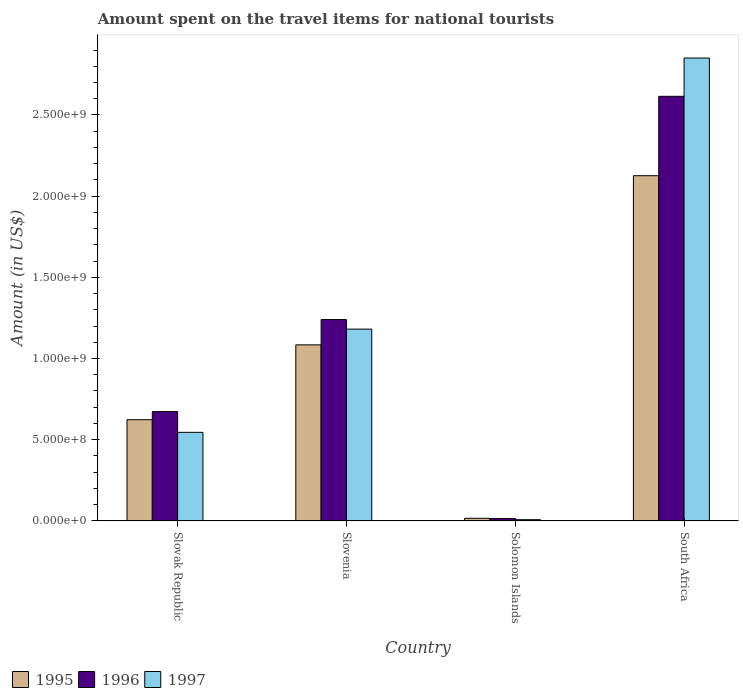Are the number of bars on each tick of the X-axis equal?
Your answer should be compact. Yes. How many bars are there on the 3rd tick from the right?
Provide a succinct answer. 3. What is the label of the 1st group of bars from the left?
Give a very brief answer. Slovak Republic. What is the amount spent on the travel items for national tourists in 1995 in Slovak Republic?
Give a very brief answer. 6.23e+08. Across all countries, what is the maximum amount spent on the travel items for national tourists in 1997?
Your answer should be compact. 2.85e+09. Across all countries, what is the minimum amount spent on the travel items for national tourists in 1996?
Make the answer very short. 1.39e+07. In which country was the amount spent on the travel items for national tourists in 1995 maximum?
Give a very brief answer. South Africa. In which country was the amount spent on the travel items for national tourists in 1995 minimum?
Provide a succinct answer. Solomon Islands. What is the total amount spent on the travel items for national tourists in 1995 in the graph?
Give a very brief answer. 3.85e+09. What is the difference between the amount spent on the travel items for national tourists in 1996 in Slovenia and that in Solomon Islands?
Your response must be concise. 1.23e+09. What is the difference between the amount spent on the travel items for national tourists in 1995 in Slovak Republic and the amount spent on the travel items for national tourists in 1996 in Slovenia?
Provide a succinct answer. -6.17e+08. What is the average amount spent on the travel items for national tourists in 1996 per country?
Give a very brief answer. 1.14e+09. What is the difference between the amount spent on the travel items for national tourists of/in 1997 and amount spent on the travel items for national tourists of/in 1996 in South Africa?
Provide a succinct answer. 2.36e+08. In how many countries, is the amount spent on the travel items for national tourists in 1997 greater than 2300000000 US$?
Provide a succinct answer. 1. What is the ratio of the amount spent on the travel items for national tourists in 1997 in Slovak Republic to that in Slovenia?
Your answer should be very brief. 0.46. Is the amount spent on the travel items for national tourists in 1996 in Slovenia less than that in Solomon Islands?
Your answer should be compact. No. What is the difference between the highest and the second highest amount spent on the travel items for national tourists in 1997?
Provide a succinct answer. 2.31e+09. What is the difference between the highest and the lowest amount spent on the travel items for national tourists in 1997?
Give a very brief answer. 2.84e+09. Is the sum of the amount spent on the travel items for national tourists in 1997 in Solomon Islands and South Africa greater than the maximum amount spent on the travel items for national tourists in 1996 across all countries?
Keep it short and to the point. Yes. What does the 2nd bar from the left in Slovenia represents?
Keep it short and to the point. 1996. Does the graph contain grids?
Keep it short and to the point. No. How many legend labels are there?
Give a very brief answer. 3. How are the legend labels stacked?
Your answer should be compact. Horizontal. What is the title of the graph?
Provide a succinct answer. Amount spent on the travel items for national tourists. Does "1985" appear as one of the legend labels in the graph?
Provide a succinct answer. No. What is the label or title of the X-axis?
Make the answer very short. Country. What is the label or title of the Y-axis?
Your answer should be very brief. Amount (in US$). What is the Amount (in US$) of 1995 in Slovak Republic?
Ensure brevity in your answer.  6.23e+08. What is the Amount (in US$) of 1996 in Slovak Republic?
Offer a terse response. 6.73e+08. What is the Amount (in US$) in 1997 in Slovak Republic?
Keep it short and to the point. 5.45e+08. What is the Amount (in US$) of 1995 in Slovenia?
Give a very brief answer. 1.08e+09. What is the Amount (in US$) of 1996 in Slovenia?
Make the answer very short. 1.24e+09. What is the Amount (in US$) in 1997 in Slovenia?
Ensure brevity in your answer.  1.18e+09. What is the Amount (in US$) of 1995 in Solomon Islands?
Your answer should be compact. 1.57e+07. What is the Amount (in US$) of 1996 in Solomon Islands?
Provide a succinct answer. 1.39e+07. What is the Amount (in US$) of 1997 in Solomon Islands?
Provide a short and direct response. 7.10e+06. What is the Amount (in US$) in 1995 in South Africa?
Your answer should be compact. 2.13e+09. What is the Amount (in US$) in 1996 in South Africa?
Offer a very short reply. 2.62e+09. What is the Amount (in US$) in 1997 in South Africa?
Your response must be concise. 2.85e+09. Across all countries, what is the maximum Amount (in US$) of 1995?
Provide a succinct answer. 2.13e+09. Across all countries, what is the maximum Amount (in US$) in 1996?
Ensure brevity in your answer.  2.62e+09. Across all countries, what is the maximum Amount (in US$) of 1997?
Your response must be concise. 2.85e+09. Across all countries, what is the minimum Amount (in US$) in 1995?
Provide a succinct answer. 1.57e+07. Across all countries, what is the minimum Amount (in US$) in 1996?
Your response must be concise. 1.39e+07. Across all countries, what is the minimum Amount (in US$) in 1997?
Provide a short and direct response. 7.10e+06. What is the total Amount (in US$) of 1995 in the graph?
Your response must be concise. 3.85e+09. What is the total Amount (in US$) of 1996 in the graph?
Ensure brevity in your answer.  4.54e+09. What is the total Amount (in US$) in 1997 in the graph?
Keep it short and to the point. 4.58e+09. What is the difference between the Amount (in US$) in 1995 in Slovak Republic and that in Slovenia?
Offer a terse response. -4.61e+08. What is the difference between the Amount (in US$) of 1996 in Slovak Republic and that in Slovenia?
Keep it short and to the point. -5.67e+08. What is the difference between the Amount (in US$) in 1997 in Slovak Republic and that in Slovenia?
Your answer should be very brief. -6.36e+08. What is the difference between the Amount (in US$) in 1995 in Slovak Republic and that in Solomon Islands?
Give a very brief answer. 6.07e+08. What is the difference between the Amount (in US$) in 1996 in Slovak Republic and that in Solomon Islands?
Your response must be concise. 6.59e+08. What is the difference between the Amount (in US$) in 1997 in Slovak Republic and that in Solomon Islands?
Your response must be concise. 5.38e+08. What is the difference between the Amount (in US$) in 1995 in Slovak Republic and that in South Africa?
Keep it short and to the point. -1.50e+09. What is the difference between the Amount (in US$) of 1996 in Slovak Republic and that in South Africa?
Your answer should be very brief. -1.94e+09. What is the difference between the Amount (in US$) in 1997 in Slovak Republic and that in South Africa?
Make the answer very short. -2.31e+09. What is the difference between the Amount (in US$) in 1995 in Slovenia and that in Solomon Islands?
Offer a very short reply. 1.07e+09. What is the difference between the Amount (in US$) in 1996 in Slovenia and that in Solomon Islands?
Give a very brief answer. 1.23e+09. What is the difference between the Amount (in US$) in 1997 in Slovenia and that in Solomon Islands?
Offer a very short reply. 1.17e+09. What is the difference between the Amount (in US$) in 1995 in Slovenia and that in South Africa?
Give a very brief answer. -1.04e+09. What is the difference between the Amount (in US$) in 1996 in Slovenia and that in South Africa?
Make the answer very short. -1.38e+09. What is the difference between the Amount (in US$) of 1997 in Slovenia and that in South Africa?
Make the answer very short. -1.67e+09. What is the difference between the Amount (in US$) in 1995 in Solomon Islands and that in South Africa?
Your answer should be compact. -2.11e+09. What is the difference between the Amount (in US$) of 1996 in Solomon Islands and that in South Africa?
Keep it short and to the point. -2.60e+09. What is the difference between the Amount (in US$) in 1997 in Solomon Islands and that in South Africa?
Your response must be concise. -2.84e+09. What is the difference between the Amount (in US$) in 1995 in Slovak Republic and the Amount (in US$) in 1996 in Slovenia?
Your answer should be very brief. -6.17e+08. What is the difference between the Amount (in US$) of 1995 in Slovak Republic and the Amount (in US$) of 1997 in Slovenia?
Ensure brevity in your answer.  -5.58e+08. What is the difference between the Amount (in US$) of 1996 in Slovak Republic and the Amount (in US$) of 1997 in Slovenia?
Your answer should be very brief. -5.08e+08. What is the difference between the Amount (in US$) in 1995 in Slovak Republic and the Amount (in US$) in 1996 in Solomon Islands?
Your answer should be very brief. 6.09e+08. What is the difference between the Amount (in US$) in 1995 in Slovak Republic and the Amount (in US$) in 1997 in Solomon Islands?
Make the answer very short. 6.16e+08. What is the difference between the Amount (in US$) of 1996 in Slovak Republic and the Amount (in US$) of 1997 in Solomon Islands?
Make the answer very short. 6.66e+08. What is the difference between the Amount (in US$) of 1995 in Slovak Republic and the Amount (in US$) of 1996 in South Africa?
Your answer should be compact. -1.99e+09. What is the difference between the Amount (in US$) in 1995 in Slovak Republic and the Amount (in US$) in 1997 in South Africa?
Offer a terse response. -2.23e+09. What is the difference between the Amount (in US$) of 1996 in Slovak Republic and the Amount (in US$) of 1997 in South Africa?
Your answer should be very brief. -2.18e+09. What is the difference between the Amount (in US$) in 1995 in Slovenia and the Amount (in US$) in 1996 in Solomon Islands?
Your response must be concise. 1.07e+09. What is the difference between the Amount (in US$) in 1995 in Slovenia and the Amount (in US$) in 1997 in Solomon Islands?
Offer a very short reply. 1.08e+09. What is the difference between the Amount (in US$) in 1996 in Slovenia and the Amount (in US$) in 1997 in Solomon Islands?
Give a very brief answer. 1.23e+09. What is the difference between the Amount (in US$) in 1995 in Slovenia and the Amount (in US$) in 1996 in South Africa?
Give a very brief answer. -1.53e+09. What is the difference between the Amount (in US$) of 1995 in Slovenia and the Amount (in US$) of 1997 in South Africa?
Offer a very short reply. -1.77e+09. What is the difference between the Amount (in US$) in 1996 in Slovenia and the Amount (in US$) in 1997 in South Africa?
Your response must be concise. -1.61e+09. What is the difference between the Amount (in US$) of 1995 in Solomon Islands and the Amount (in US$) of 1996 in South Africa?
Your answer should be compact. -2.60e+09. What is the difference between the Amount (in US$) in 1995 in Solomon Islands and the Amount (in US$) in 1997 in South Africa?
Your answer should be very brief. -2.84e+09. What is the difference between the Amount (in US$) in 1996 in Solomon Islands and the Amount (in US$) in 1997 in South Africa?
Make the answer very short. -2.84e+09. What is the average Amount (in US$) of 1995 per country?
Your answer should be very brief. 9.62e+08. What is the average Amount (in US$) of 1996 per country?
Ensure brevity in your answer.  1.14e+09. What is the average Amount (in US$) in 1997 per country?
Your answer should be very brief. 1.15e+09. What is the difference between the Amount (in US$) in 1995 and Amount (in US$) in 1996 in Slovak Republic?
Keep it short and to the point. -5.00e+07. What is the difference between the Amount (in US$) of 1995 and Amount (in US$) of 1997 in Slovak Republic?
Give a very brief answer. 7.80e+07. What is the difference between the Amount (in US$) in 1996 and Amount (in US$) in 1997 in Slovak Republic?
Your answer should be compact. 1.28e+08. What is the difference between the Amount (in US$) in 1995 and Amount (in US$) in 1996 in Slovenia?
Offer a terse response. -1.56e+08. What is the difference between the Amount (in US$) of 1995 and Amount (in US$) of 1997 in Slovenia?
Provide a succinct answer. -9.70e+07. What is the difference between the Amount (in US$) in 1996 and Amount (in US$) in 1997 in Slovenia?
Offer a terse response. 5.90e+07. What is the difference between the Amount (in US$) in 1995 and Amount (in US$) in 1996 in Solomon Islands?
Offer a terse response. 1.80e+06. What is the difference between the Amount (in US$) of 1995 and Amount (in US$) of 1997 in Solomon Islands?
Your answer should be compact. 8.60e+06. What is the difference between the Amount (in US$) of 1996 and Amount (in US$) of 1997 in Solomon Islands?
Make the answer very short. 6.80e+06. What is the difference between the Amount (in US$) of 1995 and Amount (in US$) of 1996 in South Africa?
Your answer should be compact. -4.89e+08. What is the difference between the Amount (in US$) in 1995 and Amount (in US$) in 1997 in South Africa?
Ensure brevity in your answer.  -7.25e+08. What is the difference between the Amount (in US$) in 1996 and Amount (in US$) in 1997 in South Africa?
Provide a succinct answer. -2.36e+08. What is the ratio of the Amount (in US$) of 1995 in Slovak Republic to that in Slovenia?
Offer a very short reply. 0.57. What is the ratio of the Amount (in US$) in 1996 in Slovak Republic to that in Slovenia?
Your answer should be compact. 0.54. What is the ratio of the Amount (in US$) in 1997 in Slovak Republic to that in Slovenia?
Provide a short and direct response. 0.46. What is the ratio of the Amount (in US$) of 1995 in Slovak Republic to that in Solomon Islands?
Your answer should be compact. 39.68. What is the ratio of the Amount (in US$) in 1996 in Slovak Republic to that in Solomon Islands?
Your answer should be very brief. 48.42. What is the ratio of the Amount (in US$) of 1997 in Slovak Republic to that in Solomon Islands?
Provide a short and direct response. 76.76. What is the ratio of the Amount (in US$) of 1995 in Slovak Republic to that in South Africa?
Give a very brief answer. 0.29. What is the ratio of the Amount (in US$) of 1996 in Slovak Republic to that in South Africa?
Your answer should be very brief. 0.26. What is the ratio of the Amount (in US$) of 1997 in Slovak Republic to that in South Africa?
Provide a succinct answer. 0.19. What is the ratio of the Amount (in US$) in 1995 in Slovenia to that in Solomon Islands?
Offer a very short reply. 69.04. What is the ratio of the Amount (in US$) in 1996 in Slovenia to that in Solomon Islands?
Keep it short and to the point. 89.21. What is the ratio of the Amount (in US$) of 1997 in Slovenia to that in Solomon Islands?
Provide a short and direct response. 166.34. What is the ratio of the Amount (in US$) in 1995 in Slovenia to that in South Africa?
Offer a very short reply. 0.51. What is the ratio of the Amount (in US$) in 1996 in Slovenia to that in South Africa?
Your answer should be compact. 0.47. What is the ratio of the Amount (in US$) of 1997 in Slovenia to that in South Africa?
Provide a short and direct response. 0.41. What is the ratio of the Amount (in US$) in 1995 in Solomon Islands to that in South Africa?
Provide a succinct answer. 0.01. What is the ratio of the Amount (in US$) in 1996 in Solomon Islands to that in South Africa?
Keep it short and to the point. 0.01. What is the ratio of the Amount (in US$) in 1997 in Solomon Islands to that in South Africa?
Keep it short and to the point. 0. What is the difference between the highest and the second highest Amount (in US$) of 1995?
Your response must be concise. 1.04e+09. What is the difference between the highest and the second highest Amount (in US$) in 1996?
Provide a succinct answer. 1.38e+09. What is the difference between the highest and the second highest Amount (in US$) in 1997?
Keep it short and to the point. 1.67e+09. What is the difference between the highest and the lowest Amount (in US$) in 1995?
Offer a very short reply. 2.11e+09. What is the difference between the highest and the lowest Amount (in US$) of 1996?
Your answer should be compact. 2.60e+09. What is the difference between the highest and the lowest Amount (in US$) of 1997?
Provide a succinct answer. 2.84e+09. 